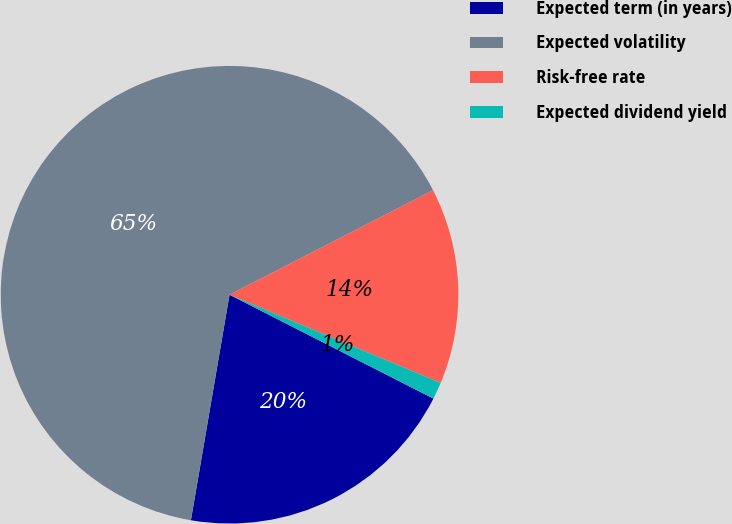Convert chart. <chart><loc_0><loc_0><loc_500><loc_500><pie_chart><fcel>Expected term (in years)<fcel>Expected volatility<fcel>Risk-free rate<fcel>Expected dividend yield<nl><fcel>20.2%<fcel>64.74%<fcel>13.85%<fcel>1.2%<nl></chart> 